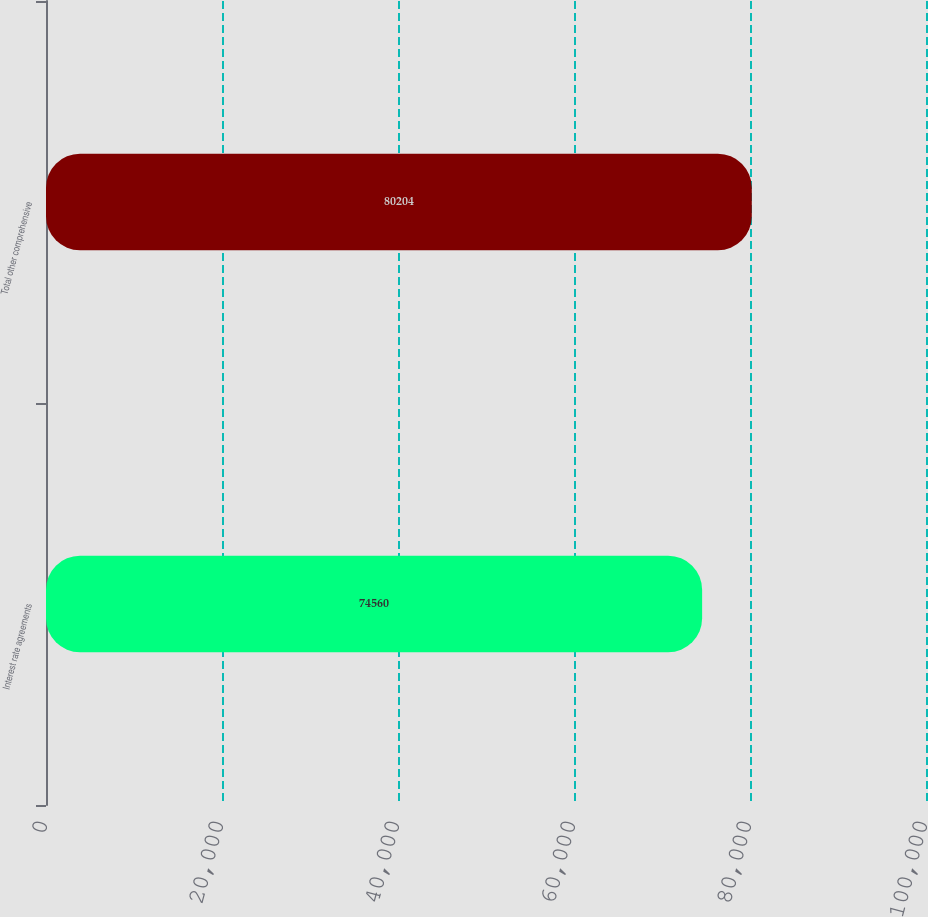<chart> <loc_0><loc_0><loc_500><loc_500><bar_chart><fcel>Interest rate agreements<fcel>Total other comprehensive<nl><fcel>74560<fcel>80204<nl></chart> 